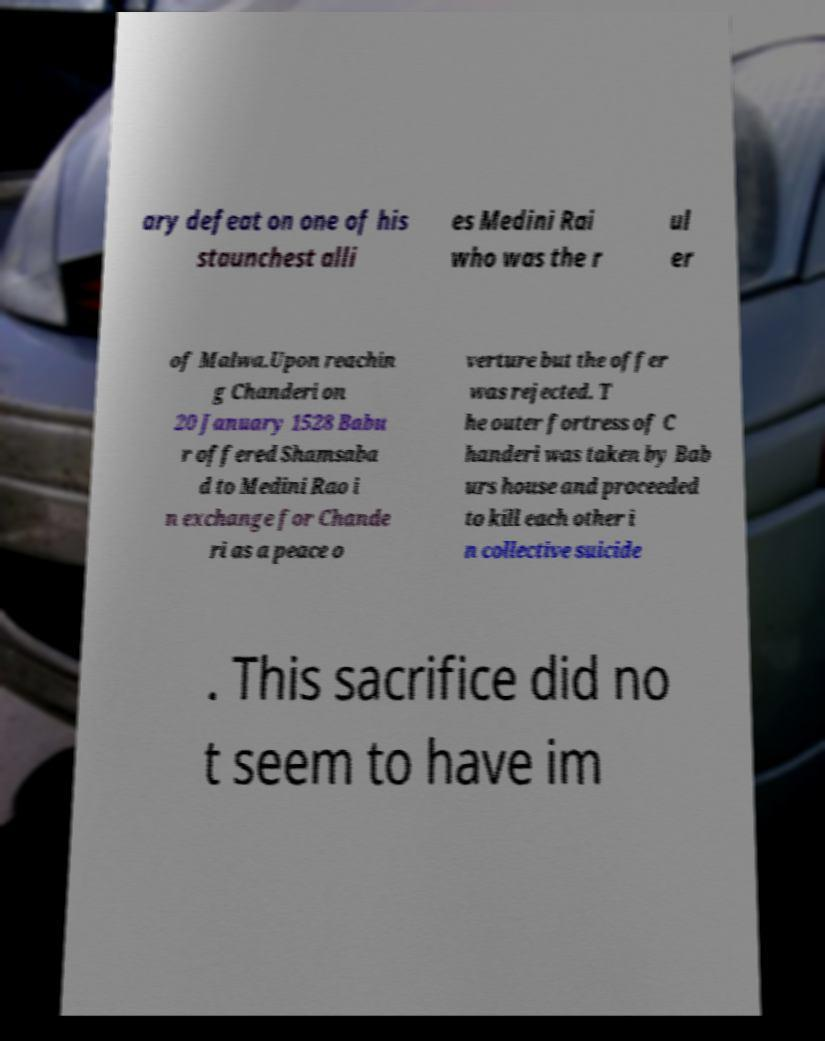Can you read and provide the text displayed in the image?This photo seems to have some interesting text. Can you extract and type it out for me? ary defeat on one of his staunchest alli es Medini Rai who was the r ul er of Malwa.Upon reachin g Chanderi on 20 January 1528 Babu r offered Shamsaba d to Medini Rao i n exchange for Chande ri as a peace o verture but the offer was rejected. T he outer fortress of C handeri was taken by Bab urs house and proceeded to kill each other i n collective suicide . This sacrifice did no t seem to have im 